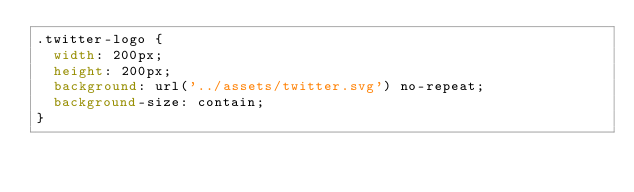<code> <loc_0><loc_0><loc_500><loc_500><_CSS_>.twitter-logo {
  width: 200px;
  height: 200px;
  background: url('../assets/twitter.svg') no-repeat;
  background-size: contain;
}
</code> 